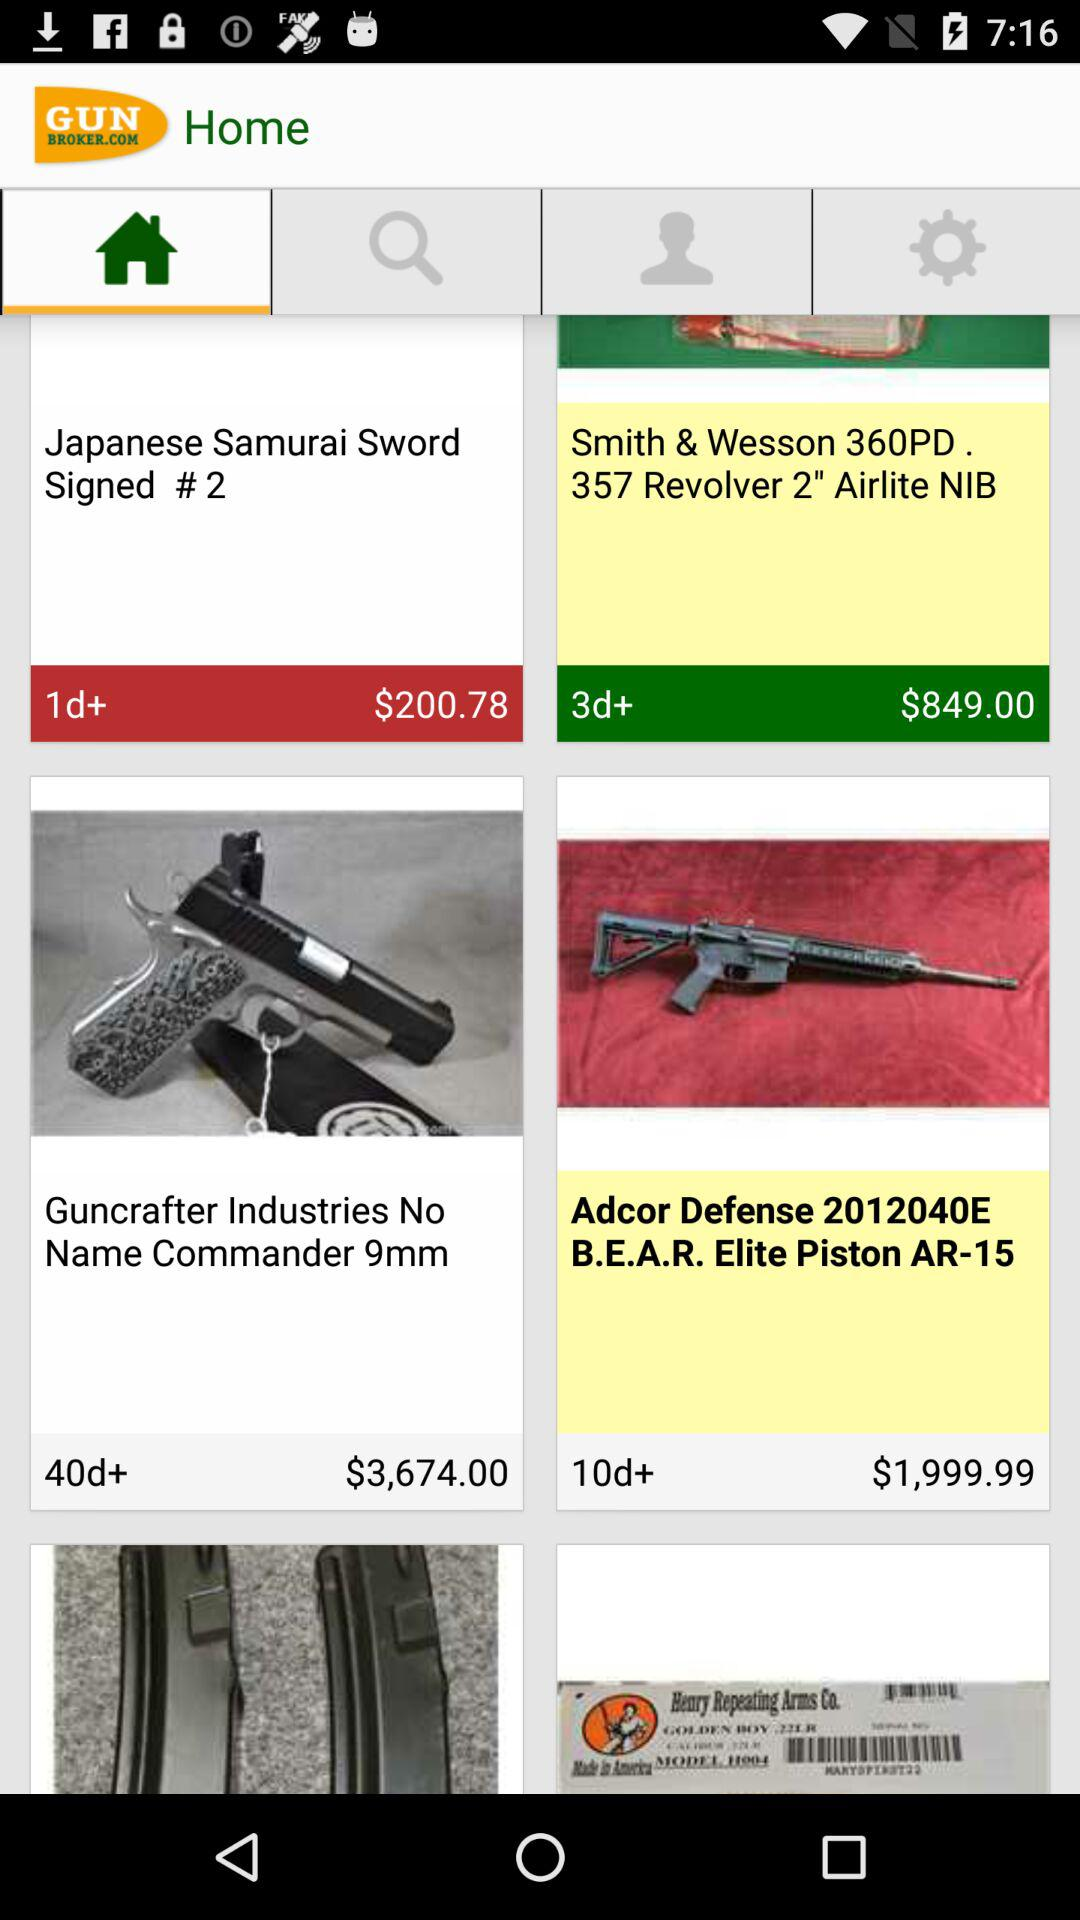What is the price of the "AR-15"? The price is $1,999.99. 